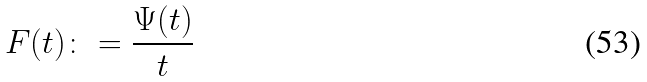<formula> <loc_0><loc_0><loc_500><loc_500>F ( t ) \colon = \frac { \Psi ( t ) } { t }</formula> 